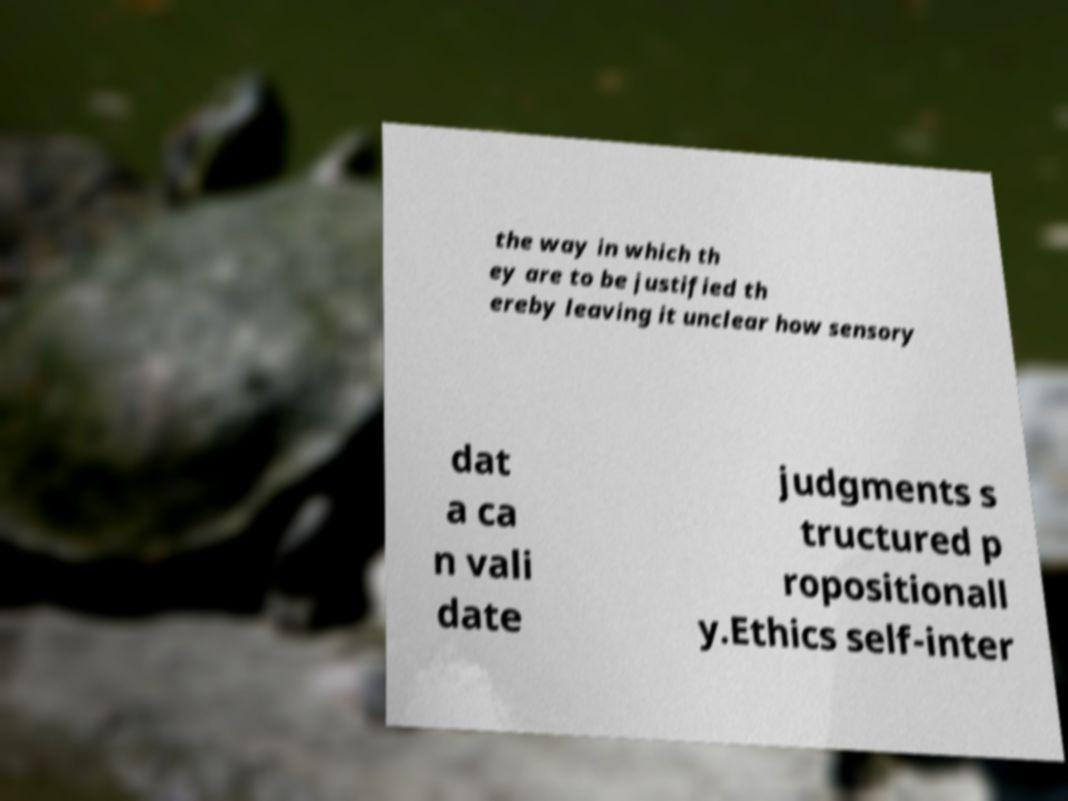What messages or text are displayed in this image? I need them in a readable, typed format. the way in which th ey are to be justified th ereby leaving it unclear how sensory dat a ca n vali date judgments s tructured p ropositionall y.Ethics self-inter 